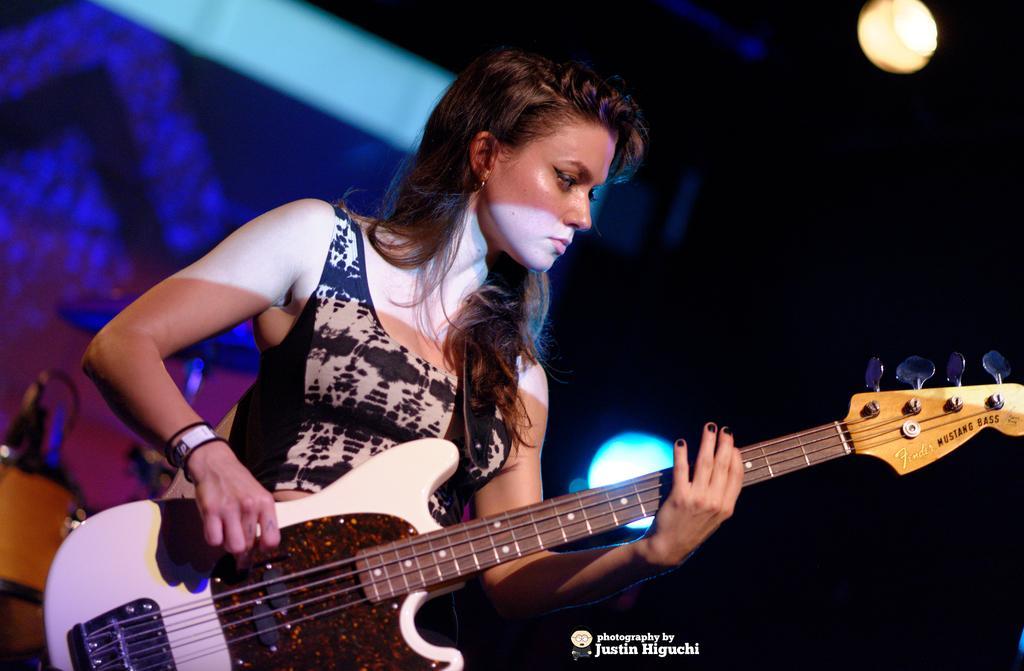In one or two sentences, can you explain what this image depicts? In this picture there is a girl who is holding the guitar in her hand and there is a stage at the left side of the image and there is a lamp above the image. 